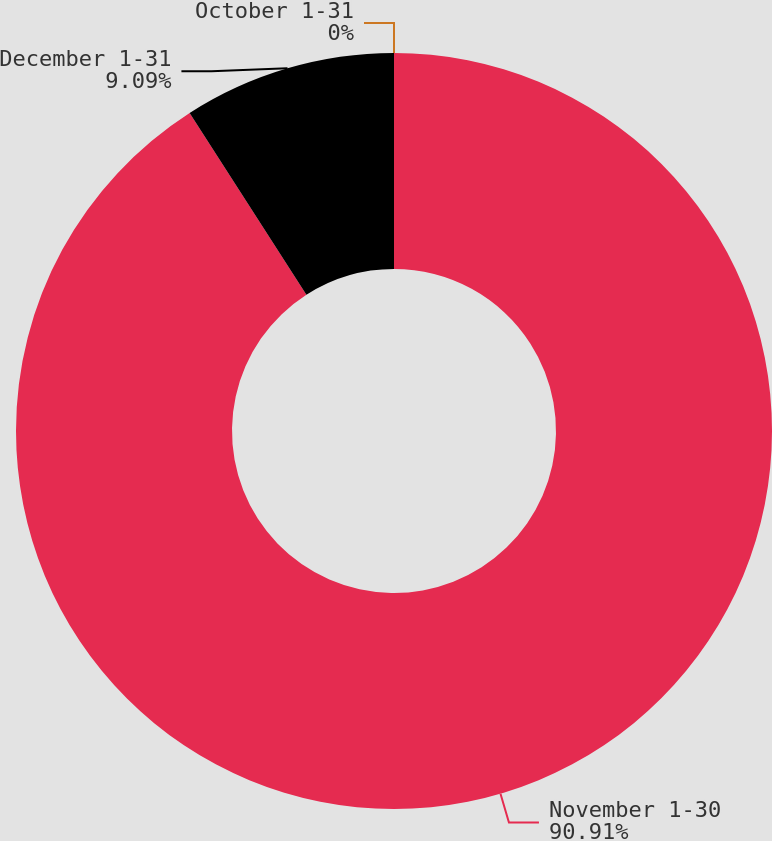<chart> <loc_0><loc_0><loc_500><loc_500><pie_chart><fcel>October 1-31<fcel>November 1-30<fcel>December 1-31<nl><fcel>0.0%<fcel>90.9%<fcel>9.09%<nl></chart> 